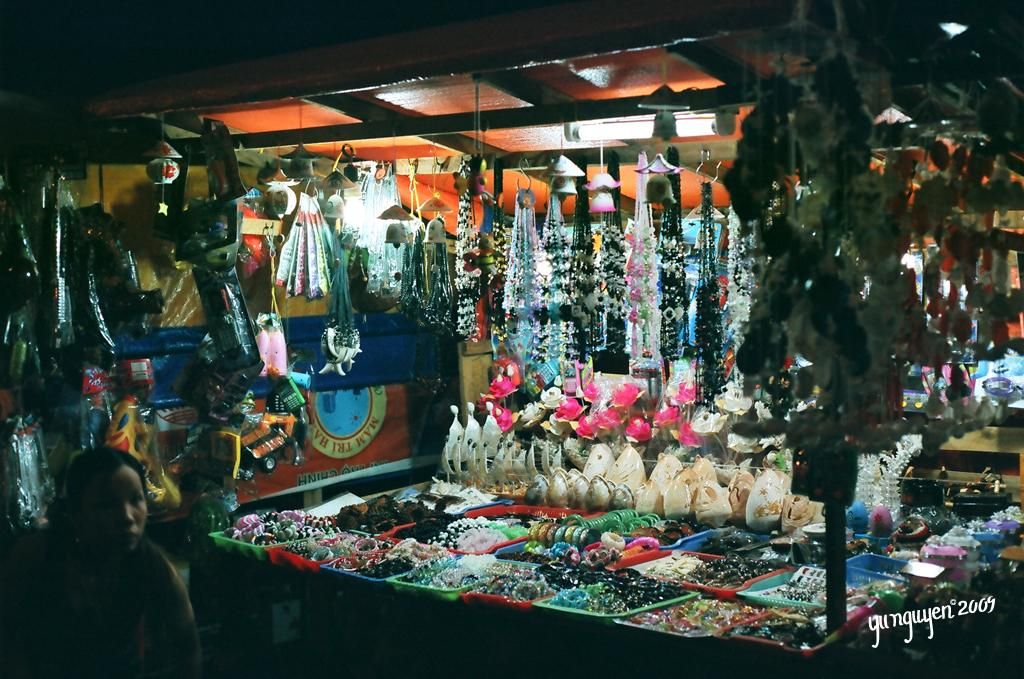What is the main subject of the image? The main subject of the image is a person standing near a shop. What can be found inside the shop? The shop contains items. Is there any text visible in the image? Yes, there is some text in the bottom right corner of the image. What type of eggs can be seen in the image? There are no eggs present in the image. What invention is being demonstrated by the person in the image? The image does not depict any specific invention or demonstration. 